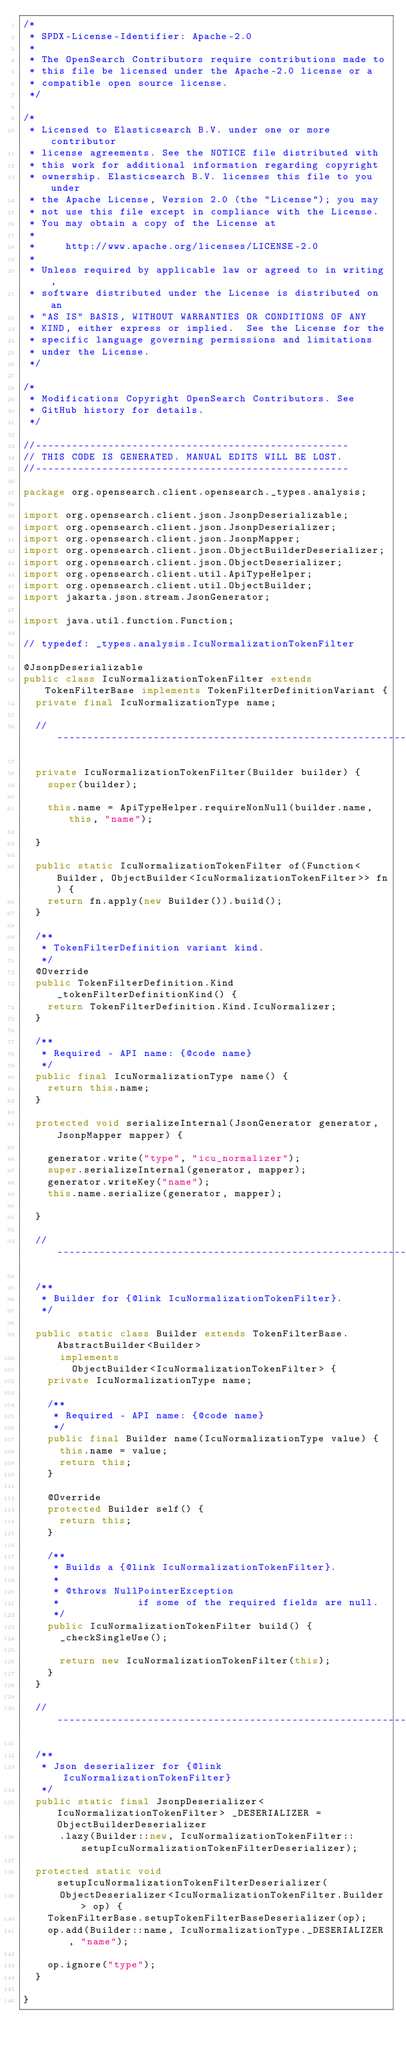<code> <loc_0><loc_0><loc_500><loc_500><_Java_>/*
 * SPDX-License-Identifier: Apache-2.0
 *
 * The OpenSearch Contributors require contributions made to
 * this file be licensed under the Apache-2.0 license or a
 * compatible open source license.
 */

/*
 * Licensed to Elasticsearch B.V. under one or more contributor
 * license agreements. See the NOTICE file distributed with
 * this work for additional information regarding copyright
 * ownership. Elasticsearch B.V. licenses this file to you under
 * the Apache License, Version 2.0 (the "License"); you may
 * not use this file except in compliance with the License.
 * You may obtain a copy of the License at
 *
 *     http://www.apache.org/licenses/LICENSE-2.0
 *
 * Unless required by applicable law or agreed to in writing,
 * software distributed under the License is distributed on an
 * "AS IS" BASIS, WITHOUT WARRANTIES OR CONDITIONS OF ANY
 * KIND, either express or implied.  See the License for the
 * specific language governing permissions and limitations
 * under the License.
 */

/*
 * Modifications Copyright OpenSearch Contributors. See
 * GitHub history for details.
 */

//----------------------------------------------------
// THIS CODE IS GENERATED. MANUAL EDITS WILL BE LOST.
//----------------------------------------------------

package org.opensearch.client.opensearch._types.analysis;

import org.opensearch.client.json.JsonpDeserializable;
import org.opensearch.client.json.JsonpDeserializer;
import org.opensearch.client.json.JsonpMapper;
import org.opensearch.client.json.ObjectBuilderDeserializer;
import org.opensearch.client.json.ObjectDeserializer;
import org.opensearch.client.util.ApiTypeHelper;
import org.opensearch.client.util.ObjectBuilder;
import jakarta.json.stream.JsonGenerator;

import java.util.function.Function;

// typedef: _types.analysis.IcuNormalizationTokenFilter

@JsonpDeserializable
public class IcuNormalizationTokenFilter extends TokenFilterBase implements TokenFilterDefinitionVariant {
	private final IcuNormalizationType name;

	// ---------------------------------------------------------------------------------------------

	private IcuNormalizationTokenFilter(Builder builder) {
		super(builder);

		this.name = ApiTypeHelper.requireNonNull(builder.name, this, "name");

	}

	public static IcuNormalizationTokenFilter of(Function<Builder, ObjectBuilder<IcuNormalizationTokenFilter>> fn) {
		return fn.apply(new Builder()).build();
	}

	/**
	 * TokenFilterDefinition variant kind.
	 */
	@Override
	public TokenFilterDefinition.Kind _tokenFilterDefinitionKind() {
		return TokenFilterDefinition.Kind.IcuNormalizer;
	}

	/**
	 * Required - API name: {@code name}
	 */
	public final IcuNormalizationType name() {
		return this.name;
	}

	protected void serializeInternal(JsonGenerator generator, JsonpMapper mapper) {

		generator.write("type", "icu_normalizer");
		super.serializeInternal(generator, mapper);
		generator.writeKey("name");
		this.name.serialize(generator, mapper);

	}

	// ---------------------------------------------------------------------------------------------

	/**
	 * Builder for {@link IcuNormalizationTokenFilter}.
	 */

	public static class Builder extends TokenFilterBase.AbstractBuilder<Builder>
			implements
				ObjectBuilder<IcuNormalizationTokenFilter> {
		private IcuNormalizationType name;

		/**
		 * Required - API name: {@code name}
		 */
		public final Builder name(IcuNormalizationType value) {
			this.name = value;
			return this;
		}

		@Override
		protected Builder self() {
			return this;
		}

		/**
		 * Builds a {@link IcuNormalizationTokenFilter}.
		 *
		 * @throws NullPointerException
		 *             if some of the required fields are null.
		 */
		public IcuNormalizationTokenFilter build() {
			_checkSingleUse();

			return new IcuNormalizationTokenFilter(this);
		}
	}

	// ---------------------------------------------------------------------------------------------

	/**
	 * Json deserializer for {@link IcuNormalizationTokenFilter}
	 */
	public static final JsonpDeserializer<IcuNormalizationTokenFilter> _DESERIALIZER = ObjectBuilderDeserializer
			.lazy(Builder::new, IcuNormalizationTokenFilter::setupIcuNormalizationTokenFilterDeserializer);

	protected static void setupIcuNormalizationTokenFilterDeserializer(
			ObjectDeserializer<IcuNormalizationTokenFilter.Builder> op) {
		TokenFilterBase.setupTokenFilterBaseDeserializer(op);
		op.add(Builder::name, IcuNormalizationType._DESERIALIZER, "name");

		op.ignore("type");
	}

}
</code> 